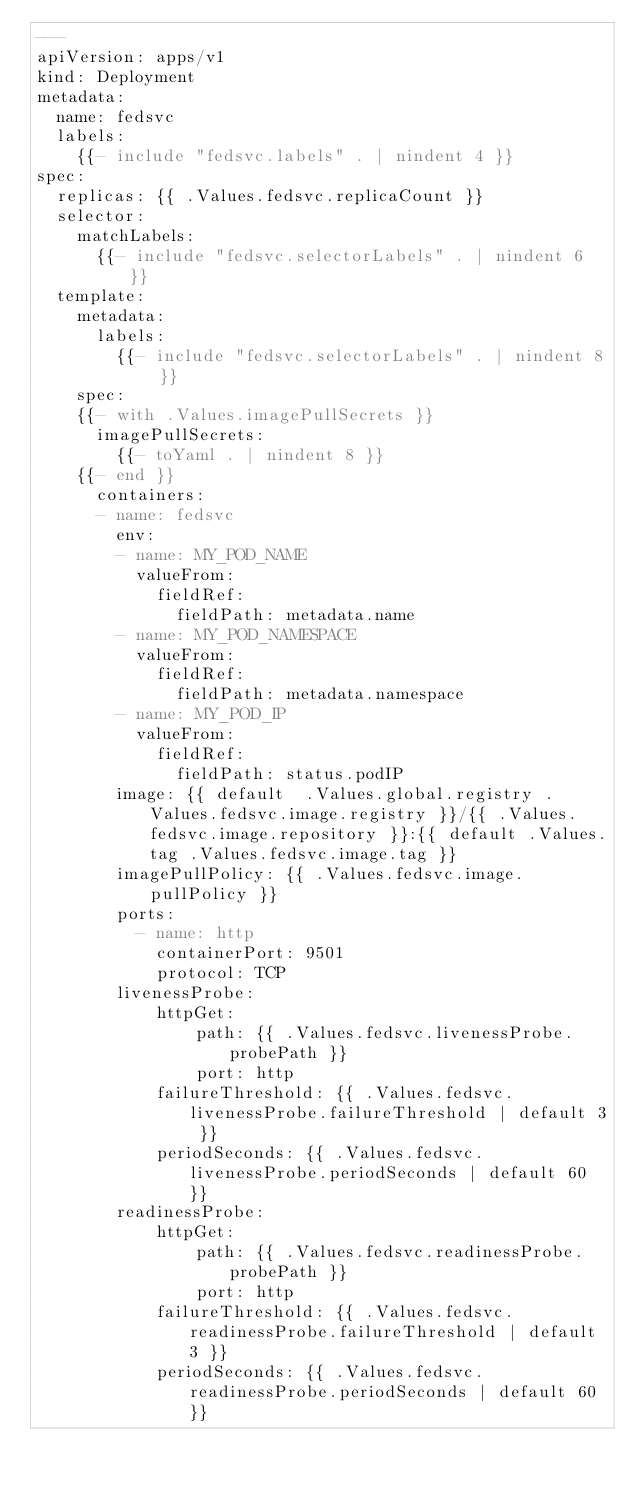Convert code to text. <code><loc_0><loc_0><loc_500><loc_500><_YAML_>---
apiVersion: apps/v1
kind: Deployment
metadata:
  name: fedsvc
  labels:
    {{- include "fedsvc.labels" . | nindent 4 }}
spec:
  replicas: {{ .Values.fedsvc.replicaCount }}
  selector:
    matchLabels:
      {{- include "fedsvc.selectorLabels" . | nindent 6 }}
  template:
    metadata:
      labels:
        {{- include "fedsvc.selectorLabels" . | nindent 8 }}
    spec:
    {{- with .Values.imagePullSecrets }}
      imagePullSecrets:
        {{- toYaml . | nindent 8 }}
    {{- end }}
      containers:
      - name: fedsvc
        env:
        - name: MY_POD_NAME
          valueFrom:
            fieldRef:
              fieldPath: metadata.name
        - name: MY_POD_NAMESPACE
          valueFrom:
            fieldRef:
              fieldPath: metadata.namespace
        - name: MY_POD_IP
          valueFrom:
            fieldRef:
              fieldPath: status.podIP
        image: {{ default  .Values.global.registry .Values.fedsvc.image.registry }}/{{ .Values.fedsvc.image.repository }}:{{ default .Values.tag .Values.fedsvc.image.tag }}
        imagePullPolicy: {{ .Values.fedsvc.image.pullPolicy }}
        ports:
          - name: http
            containerPort: 9501 
            protocol: TCP
        livenessProbe:
            httpGet:
                path: {{ .Values.fedsvc.livenessProbe.probePath }}
                port: http
            failureThreshold: {{ .Values.fedsvc.livenessProbe.failureThreshold | default 3 }}
            periodSeconds: {{ .Values.fedsvc.livenessProbe.periodSeconds | default 60 }}
        readinessProbe:
            httpGet:
                path: {{ .Values.fedsvc.readinessProbe.probePath }}
                port: http
            failureThreshold: {{ .Values.fedsvc.readinessProbe.failureThreshold | default 3 }}
            periodSeconds: {{ .Values.fedsvc.readinessProbe.periodSeconds | default 60 }}


</code> 